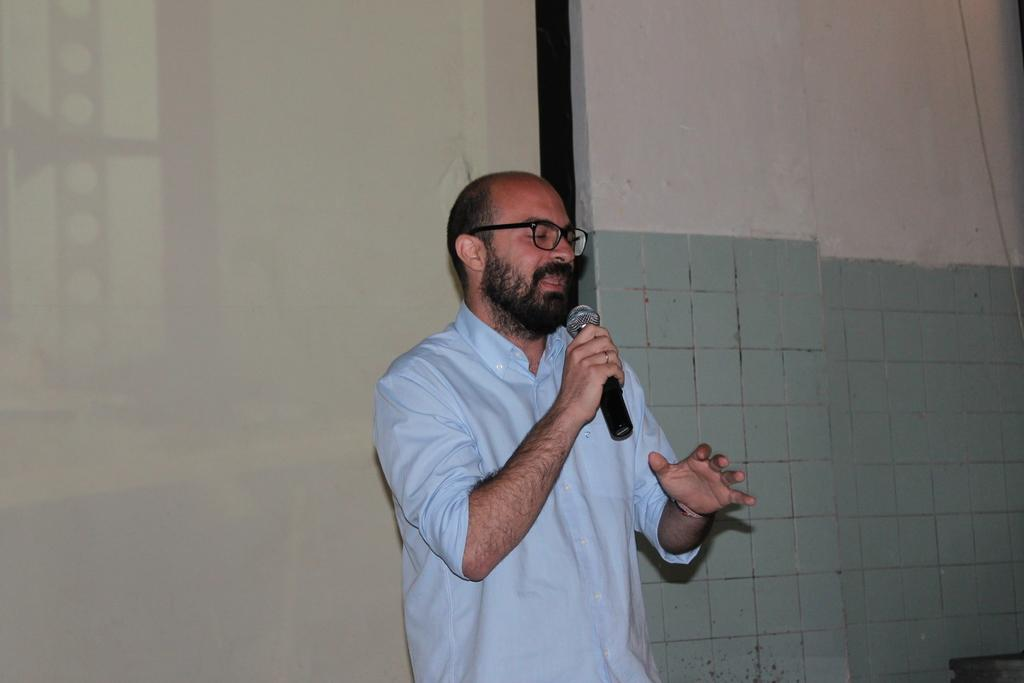Who is present in the image? There is a man in the image. What is the man wearing? The man is wearing spectacles. What is the man holding in the image? The man is holding a mic. What can be seen in the background of the image? There is a wall in the background of the image. What type of pencil is the secretary using in the image? There is no secretary or pencil present in the image. Are there any fairies visible in the image? There are no fairies present in the image. 